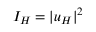Convert formula to latex. <formula><loc_0><loc_0><loc_500><loc_500>I _ { H } = | u _ { H } | ^ { 2 }</formula> 